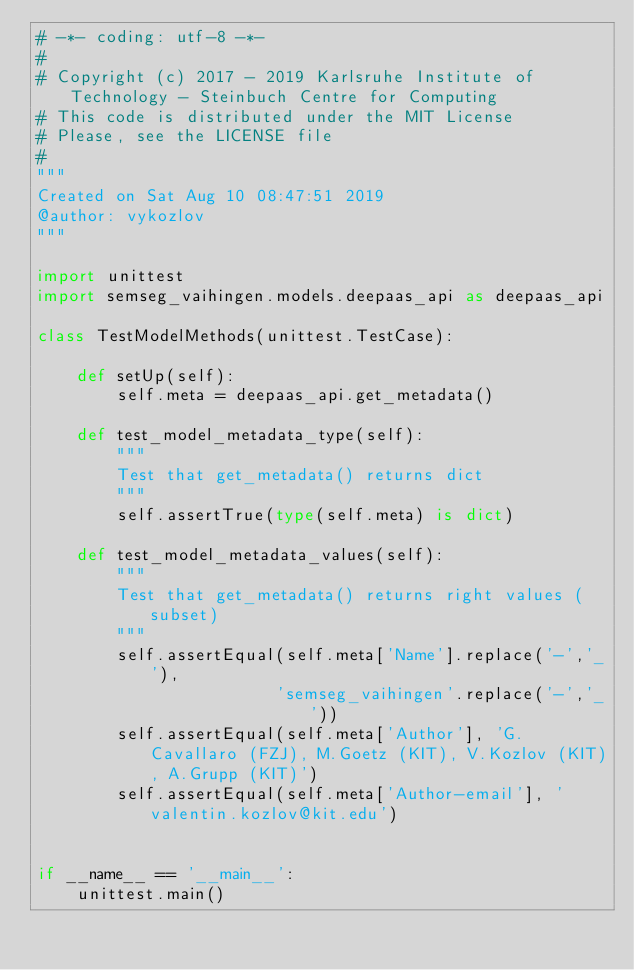<code> <loc_0><loc_0><loc_500><loc_500><_Python_># -*- coding: utf-8 -*-
#
# Copyright (c) 2017 - 2019 Karlsruhe Institute of Technology - Steinbuch Centre for Computing
# This code is distributed under the MIT License
# Please, see the LICENSE file
#
"""
Created on Sat Aug 10 08:47:51 2019
@author: vykozlov
"""

import unittest
import semseg_vaihingen.models.deepaas_api as deepaas_api

class TestModelMethods(unittest.TestCase):
    
    def setUp(self):
        self.meta = deepaas_api.get_metadata()
        
    def test_model_metadata_type(self):
        """
        Test that get_metadata() returns dict
        """
        self.assertTrue(type(self.meta) is dict)
        
    def test_model_metadata_values(self):
        """
        Test that get_metadata() returns right values (subset)
        """
        self.assertEqual(self.meta['Name'].replace('-','_'),
                        'semseg_vaihingen'.replace('-','_'))
        self.assertEqual(self.meta['Author'], 'G.Cavallaro (FZJ), M.Goetz (KIT), V.Kozlov (KIT), A.Grupp (KIT)')
        self.assertEqual(self.meta['Author-email'], 'valentin.kozlov@kit.edu')


if __name__ == '__main__':
    unittest.main()
</code> 